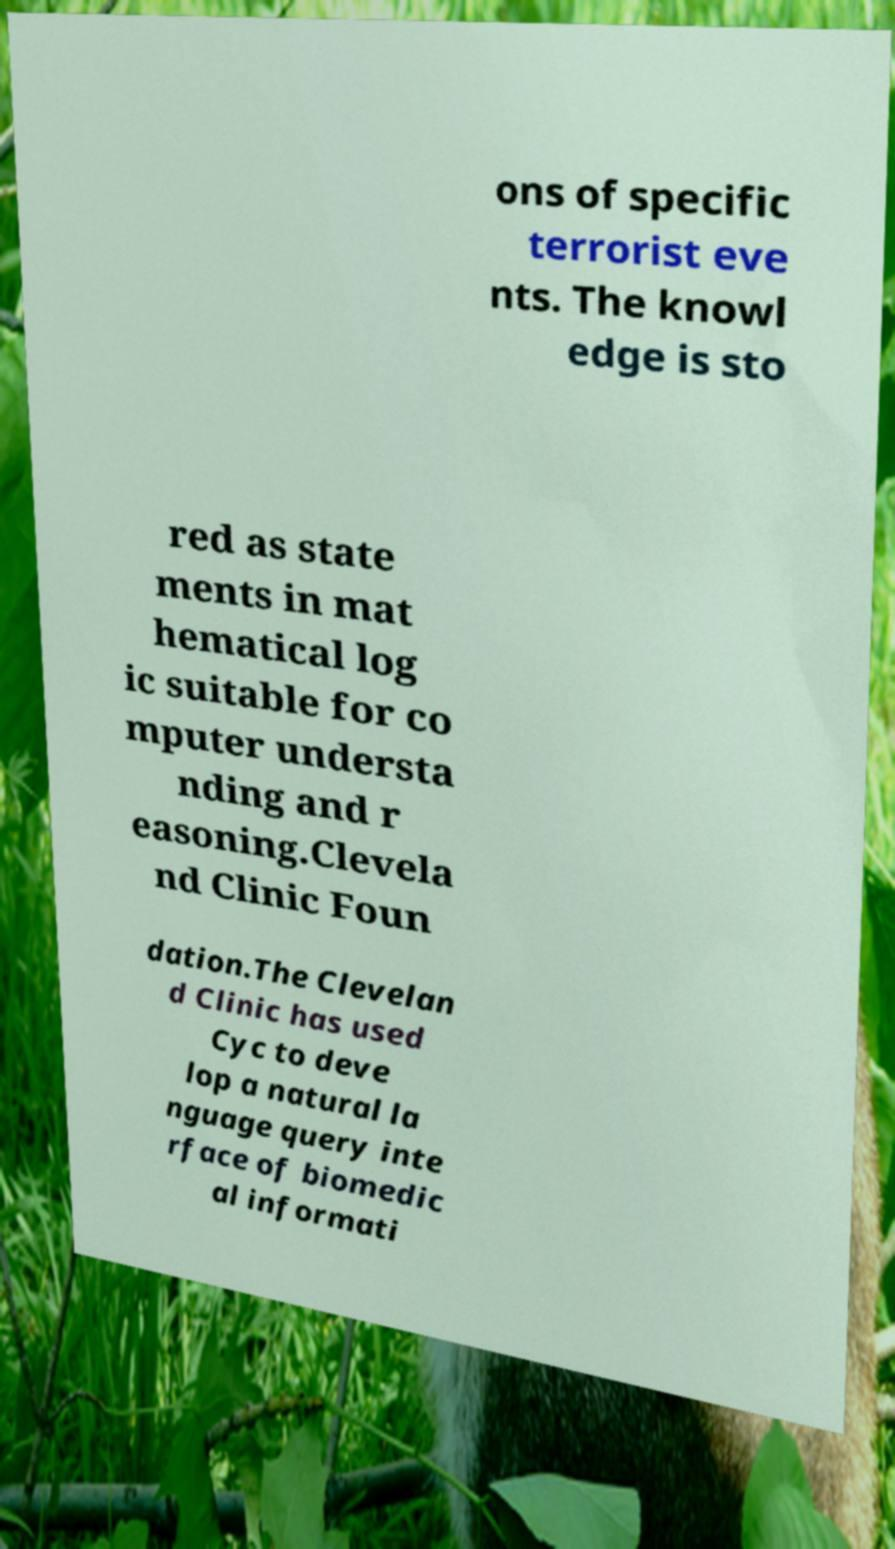I need the written content from this picture converted into text. Can you do that? ons of specific terrorist eve nts. The knowl edge is sto red as state ments in mat hematical log ic suitable for co mputer understa nding and r easoning.Clevela nd Clinic Foun dation.The Clevelan d Clinic has used Cyc to deve lop a natural la nguage query inte rface of biomedic al informati 